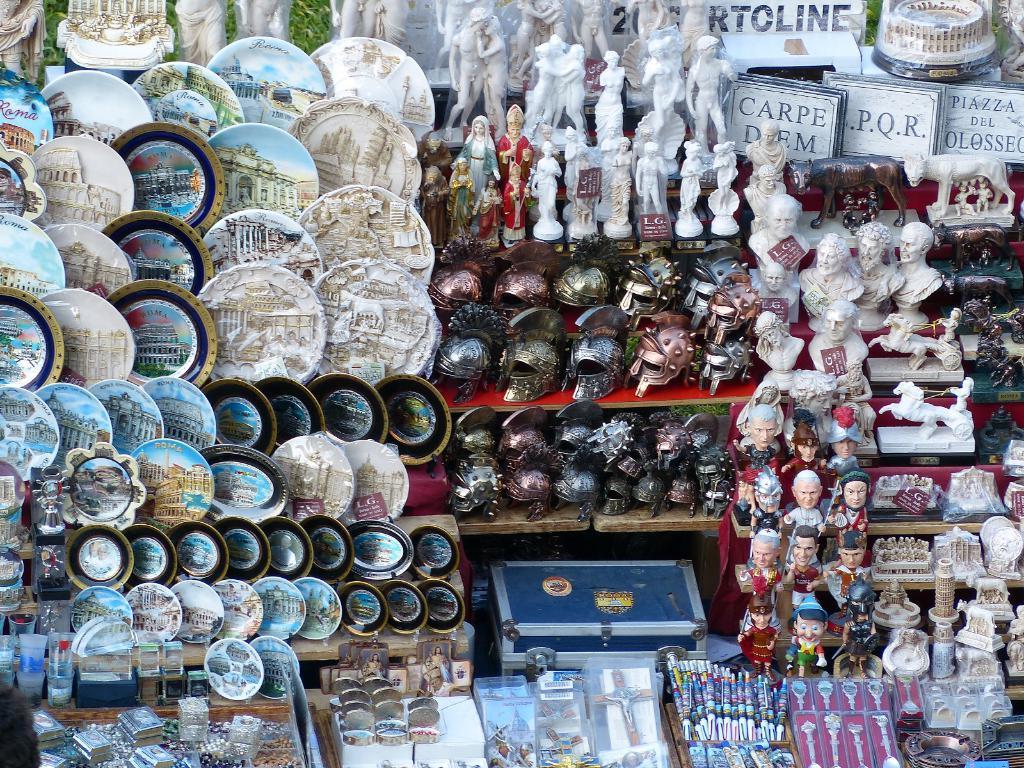Can you describe this image briefly? In this image there are many ceramic objects, in the middle there is a box, helmets, in the bottom there are watches and pens. 